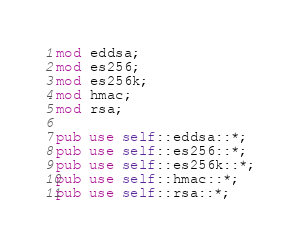<code> <loc_0><loc_0><loc_500><loc_500><_Rust_>mod eddsa;
mod es256;
mod es256k;
mod hmac;
mod rsa;

pub use self::eddsa::*;
pub use self::es256::*;
pub use self::es256k::*;
pub use self::hmac::*;
pub use self::rsa::*;
</code> 